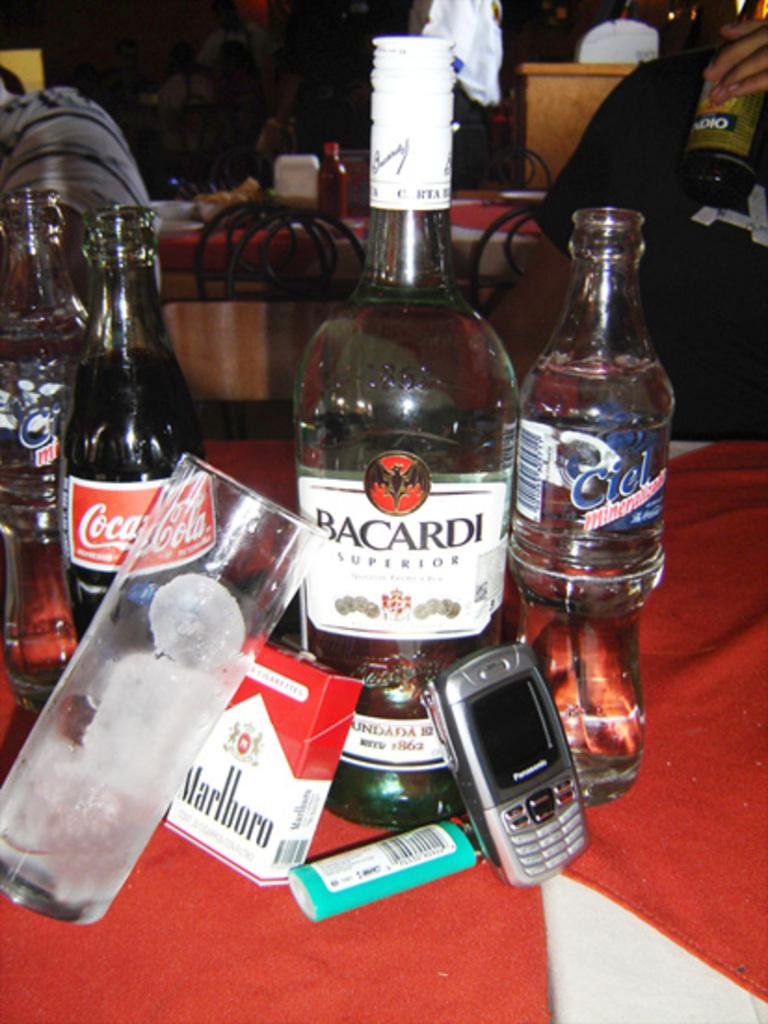<image>
Describe the image concisely. A pack of Marlboro cigarettes is leaning up against a bottle of Bacardi. 